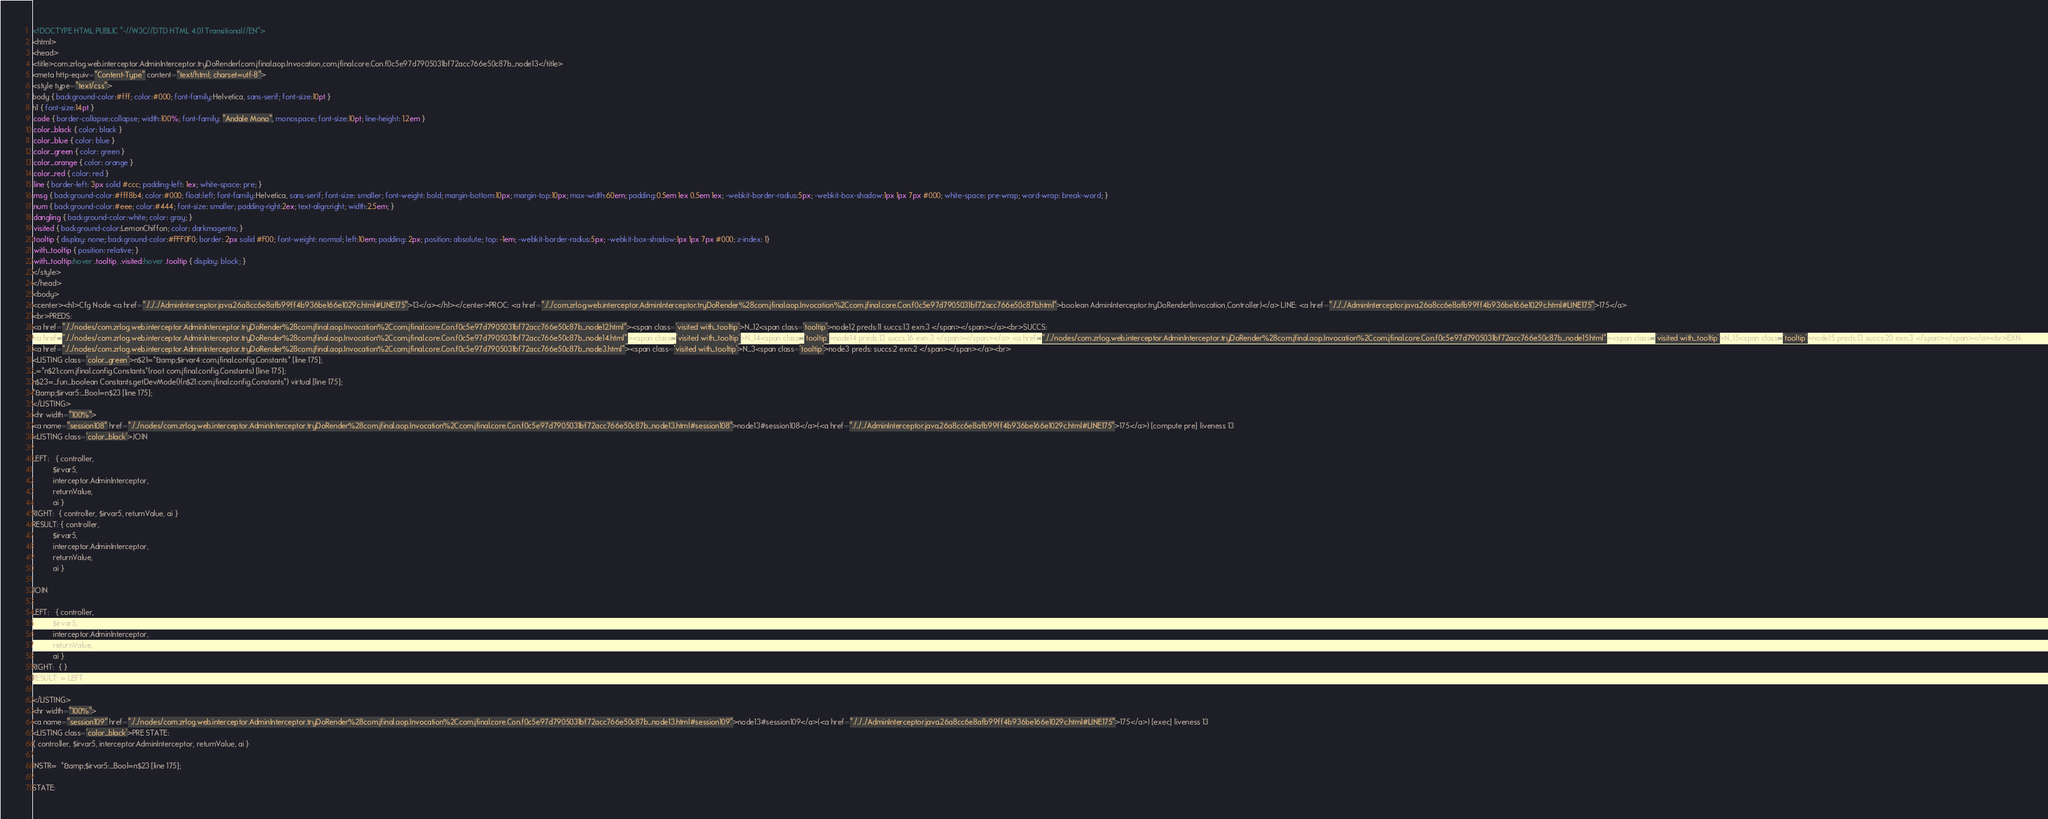<code> <loc_0><loc_0><loc_500><loc_500><_HTML_><!DOCTYPE HTML PUBLIC "-//W3C//DTD HTML 4.01 Transitional//EN">
<html>
<head>
<title>com.zrlog.web.interceptor.AdminInterceptor.tryDoRender(com.jfinal.aop.Invocation,com.jfinal.core.Con.f0c5e97d7905031bf72acc766e50c87b_node13</title>
<meta http-equiv="Content-Type" content="text/html; charset=utf-8">
<style type="text/css">
body { background-color:#fff; color:#000; font-family:Helvetica, sans-serif; font-size:10pt }
h1 { font-size:14pt }
.code { border-collapse:collapse; width:100%; font-family: "Andale Mono", monospace; font-size:10pt; line-height: 1.2em }
.color_black { color: black }
.color_blue { color: blue }
.color_green { color: green }
.color_orange { color: orange }
.color_red { color: red }
.line { border-left: 3px solid #ccc; padding-left: 1ex; white-space: pre; }
.msg { background-color:#fff8b4; color:#000; float:left; font-family:Helvetica, sans-serif; font-size: smaller; font-weight: bold; margin-bottom:10px; margin-top:10px; max-width:60em; padding:0.5em 1ex 0.5em 1ex; -webkit-border-radius:5px; -webkit-box-shadow:1px 1px 7px #000; white-space: pre-wrap; word-wrap: break-word; }
.num { background-color:#eee; color:#444; font-size: smaller; padding-right:2ex; text-align:right; width:2.5em; }
.dangling { background-color:white; color: gray; }
.visited { background-color:LemonChiffon; color: darkmagenta; }
.tooltip { display: none; background-color:#FFF0F0; border: 2px solid #F00; font-weight: normal; left:10em; padding: 2px; position: absolute; top: -1em; -webkit-border-radius:5px; -webkit-box-shadow:1px 1px 7px #000; z-index: 1}
.with_tooltip { position: relative; }
.with_tooltip:hover .tooltip, .visited:hover .tooltip { display: block; }
</style>
</head>
<body>
<center><h1>Cfg Node <a href="./../../AdminInterceptor.java.26a8cc6e8afb99ff4b936be166e1029c.html#LINE175">13</a></h1></center>PROC: <a href="./../com.zrlog.web.interceptor.AdminInterceptor.tryDoRender%28com.jfinal.aop.Invocation%2Ccom.jfinal.core.Con.f0c5e97d7905031bf72acc766e50c87b.html">boolean AdminInterceptor.tryDoRender(Invocation,Controller)</a> LINE: <a href="./../../AdminInterceptor.java.26a8cc6e8afb99ff4b936be166e1029c.html#LINE175">175</a>
<br>PREDS:
<a href="./../nodes/com.zrlog.web.interceptor.AdminInterceptor.tryDoRender%28com.jfinal.aop.Invocation%2Ccom.jfinal.core.Con.f0c5e97d7905031bf72acc766e50c87b_node12.html"><span class='visited with_tooltip'>N_12<span class='tooltip'>node12 preds:11 succs:13 exn:3 </span></span></a><br>SUCCS:
<a href="./../nodes/com.zrlog.web.interceptor.AdminInterceptor.tryDoRender%28com.jfinal.aop.Invocation%2Ccom.jfinal.core.Con.f0c5e97d7905031bf72acc766e50c87b_node14.html"><span class='visited with_tooltip'>N_14<span class='tooltip'>node14 preds:13 succs:16 exn:3 </span></span></a> <a href="./../nodes/com.zrlog.web.interceptor.AdminInterceptor.tryDoRender%28com.jfinal.aop.Invocation%2Ccom.jfinal.core.Con.f0c5e97d7905031bf72acc766e50c87b_node15.html"><span class='visited with_tooltip'>N_15<span class='tooltip'>node15 preds:13 succs:20 exn:3 </span></span></a><br>EXN:
<a href="./../nodes/com.zrlog.web.interceptor.AdminInterceptor.tryDoRender%28com.jfinal.aop.Invocation%2Ccom.jfinal.core.Con.f0c5e97d7905031bf72acc766e50c87b_node3.html"><span class='visited with_tooltip'>N_3<span class='tooltip'>node3 preds: succs:2 exn:2 </span></span></a><br>
<LISTING class='color_green'>n$21=*&amp;$irvar4:com.jfinal.config.Constants* [line 175];
_=*n$21:com.jfinal.config.Constants*(root com.jfinal.config.Constants) [line 175];
n$23=_fun_boolean Constants.getDevMode()(n$21:com.jfinal.config.Constants*) virtual [line 175];
*&amp;$irvar5:_Bool=n$23 [line 175];
</LISTING>
<hr width="100%">
<a name="session108" href="./../nodes/com.zrlog.web.interceptor.AdminInterceptor.tryDoRender%28com.jfinal.aop.Invocation%2Ccom.jfinal.core.Con.f0c5e97d7905031bf72acc766e50c87b_node13.html#session108">node13#session108</a>(<a href="./../../AdminInterceptor.java.26a8cc6e8afb99ff4b936be166e1029c.html#LINE175">175</a>) [compute pre] liveness 13
<LISTING class='color_black'>JOIN

LEFT:   { controller,
          $irvar5,
          interceptor.AdminInterceptor,
          returnValue,
          ai }
RIGHT:  { controller, $irvar5, returnValue, ai }
RESULT: { controller,
          $irvar5,
          interceptor.AdminInterceptor,
          returnValue,
          ai }

JOIN

LEFT:   { controller,
          $irvar5,
          interceptor.AdminInterceptor,
          returnValue,
          ai }
RIGHT:  { }
RESULT: = LEFT

</LISTING>
<hr width="100%">
<a name="session109" href="./../nodes/com.zrlog.web.interceptor.AdminInterceptor.tryDoRender%28com.jfinal.aop.Invocation%2Ccom.jfinal.core.Con.f0c5e97d7905031bf72acc766e50c87b_node13.html#session109">node13#session109</a>(<a href="./../../AdminInterceptor.java.26a8cc6e8afb99ff4b936be166e1029c.html#LINE175">175</a>) [exec] liveness 13
<LISTING class='color_black'>PRE STATE:
{ controller, $irvar5, interceptor.AdminInterceptor, returnValue, ai }

INSTR=  *&amp;$irvar5:_Bool=n$23 [line 175]; 

STATE:</code> 